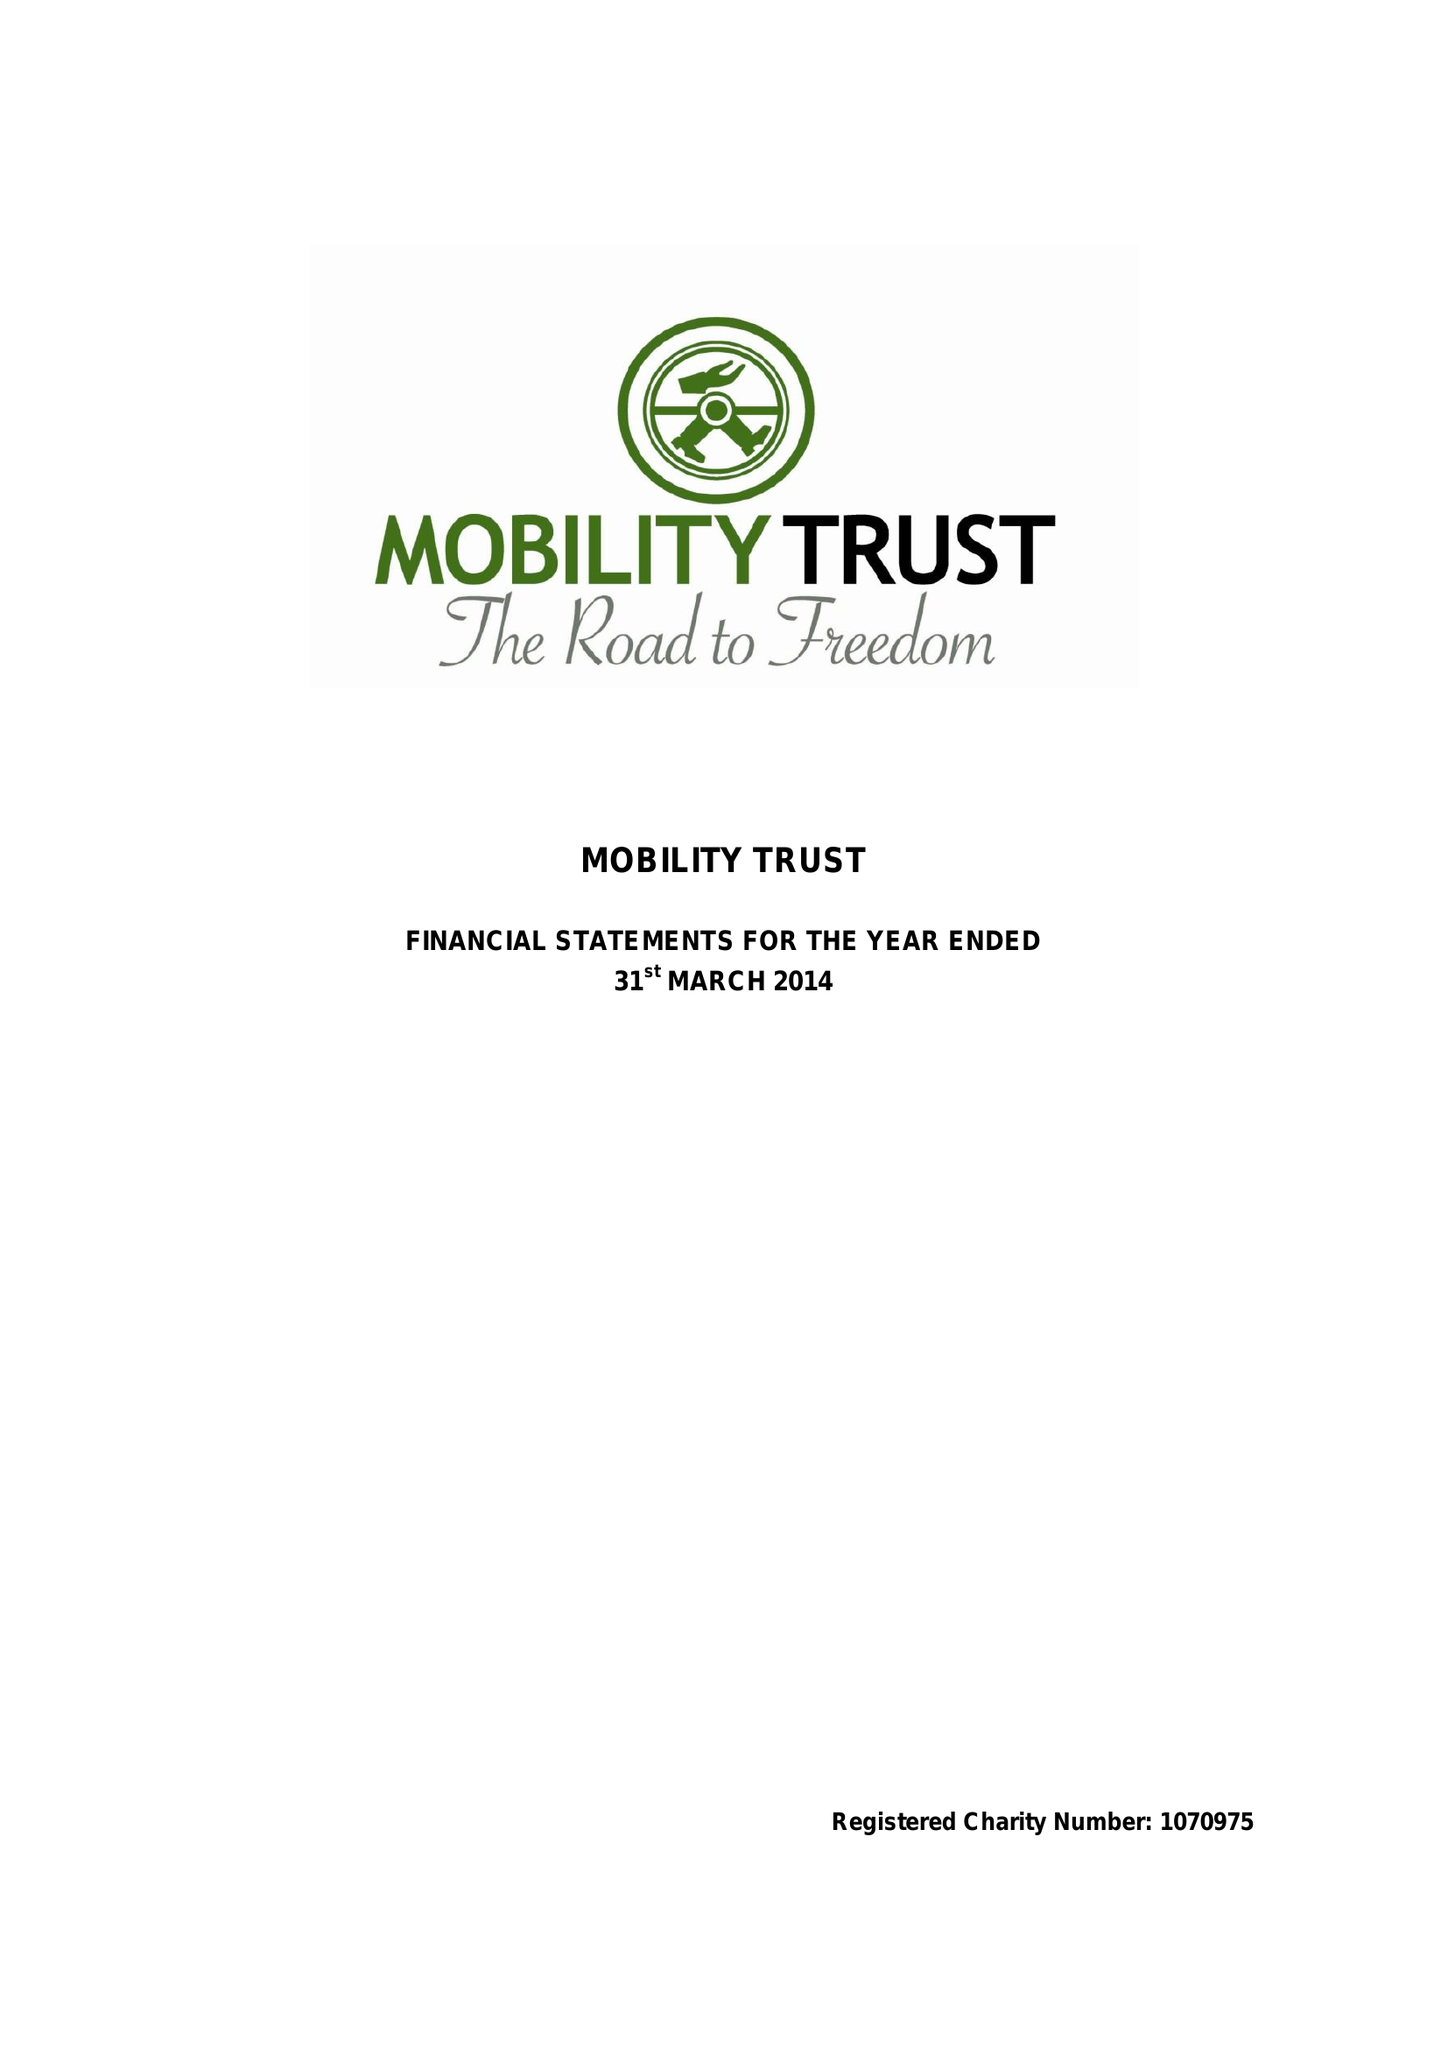What is the value for the address__post_town?
Answer the question using a single word or phrase. READING 